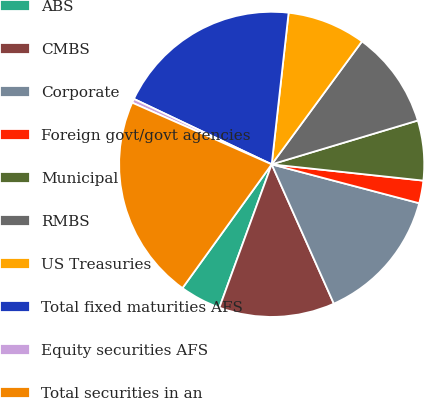<chart> <loc_0><loc_0><loc_500><loc_500><pie_chart><fcel>ABS<fcel>CMBS<fcel>Corporate<fcel>Foreign govt/govt agencies<fcel>Municipal<fcel>RMBS<fcel>US Treasuries<fcel>Total fixed maturities AFS<fcel>Equity securities AFS<fcel>Total securities in an<nl><fcel>4.37%<fcel>12.25%<fcel>14.22%<fcel>2.4%<fcel>6.34%<fcel>10.28%<fcel>8.31%<fcel>19.71%<fcel>0.43%<fcel>21.68%<nl></chart> 